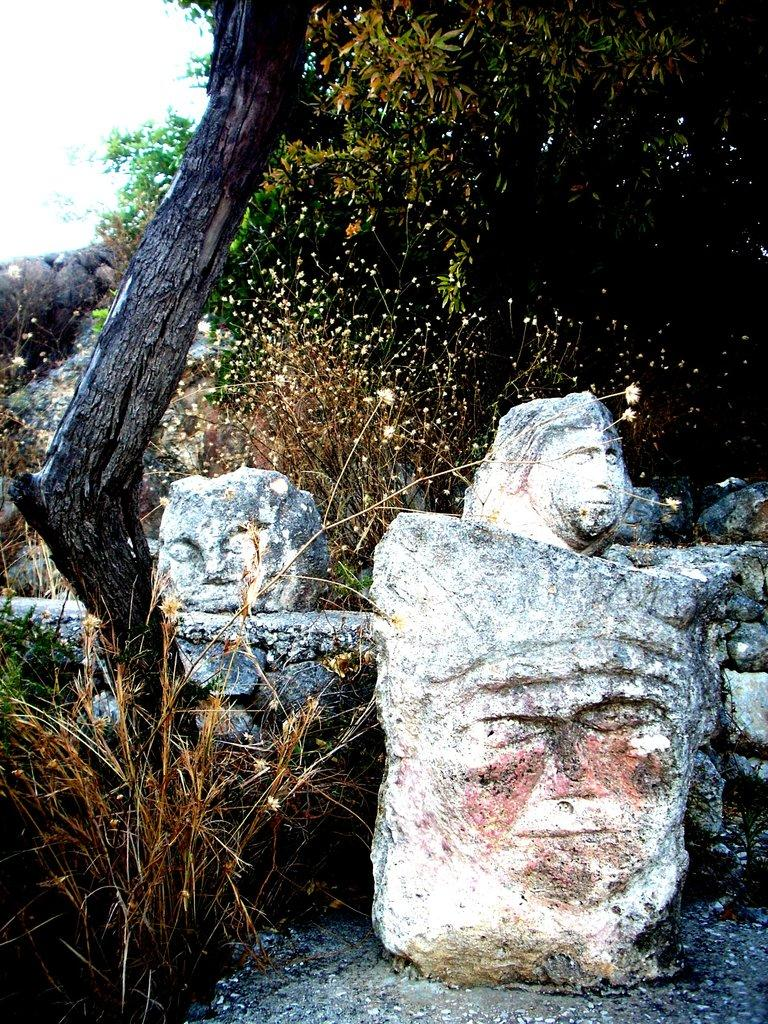What type of artwork is featured in the image? There is a stone carving in the image. What type of natural vegetation is present in the image? There are trees in the image. What is visible in the background of the image? The sky is visible in the background of the image. What type of addition problem can be seen solved on the stone carving in the image? There is no addition problem present on the stone carving in the image. Is there a gun visible in the image? No, there is no gun present in the image. What type of cap is the person wearing in the image? There is no person present in the image, so it is not possible to determine what type of cap they might be wearing. 